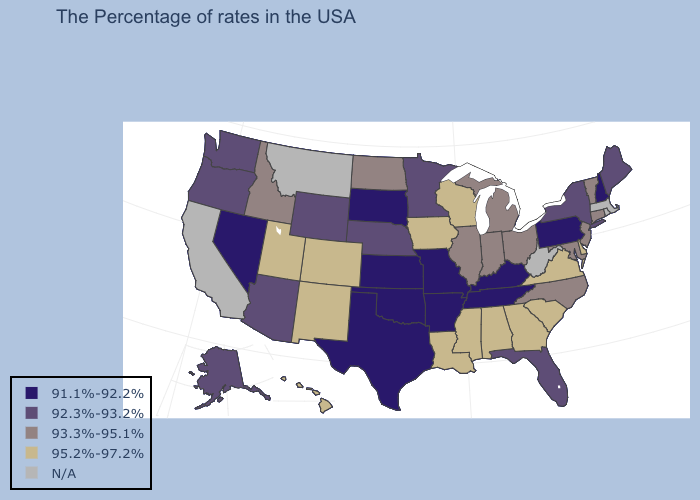Name the states that have a value in the range 95.2%-97.2%?
Write a very short answer. Delaware, Virginia, South Carolina, Georgia, Alabama, Wisconsin, Mississippi, Louisiana, Iowa, Colorado, New Mexico, Utah, Hawaii. What is the value of Kentucky?
Write a very short answer. 91.1%-92.2%. What is the lowest value in the Northeast?
Quick response, please. 91.1%-92.2%. Which states have the lowest value in the West?
Short answer required. Nevada. What is the highest value in states that border California?
Quick response, please. 92.3%-93.2%. Name the states that have a value in the range 93.3%-95.1%?
Be succinct. Vermont, Connecticut, New Jersey, Maryland, North Carolina, Ohio, Michigan, Indiana, Illinois, North Dakota, Idaho. What is the value of Washington?
Quick response, please. 92.3%-93.2%. Which states hav the highest value in the South?
Write a very short answer. Delaware, Virginia, South Carolina, Georgia, Alabama, Mississippi, Louisiana. What is the highest value in states that border Texas?
Give a very brief answer. 95.2%-97.2%. Does Alaska have the highest value in the West?
Quick response, please. No. Does South Dakota have the lowest value in the MidWest?
Answer briefly. Yes. 